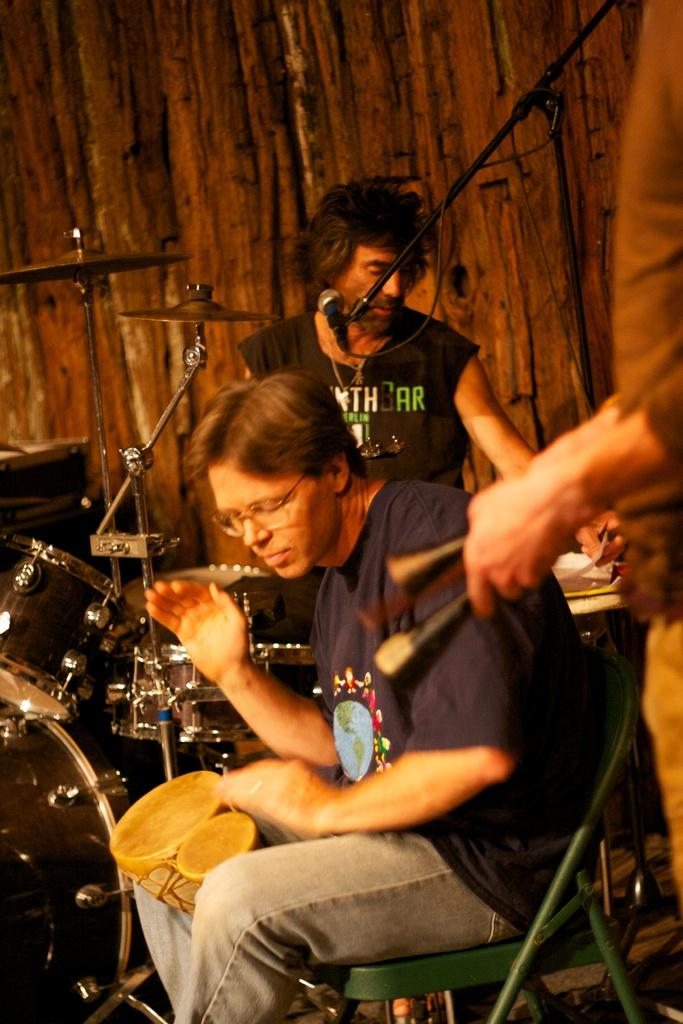How many people are in the image? There are two persons in the image. What are the persons doing in the image? The persons are sitting on chairs. What other objects can be seen in the image? There are musical instruments and a microphone (mike) in the image. What type of property is visible in the background of the image? There is no property visible in the image; it only shows two persons sitting on chairs with musical instruments and a microphone. 